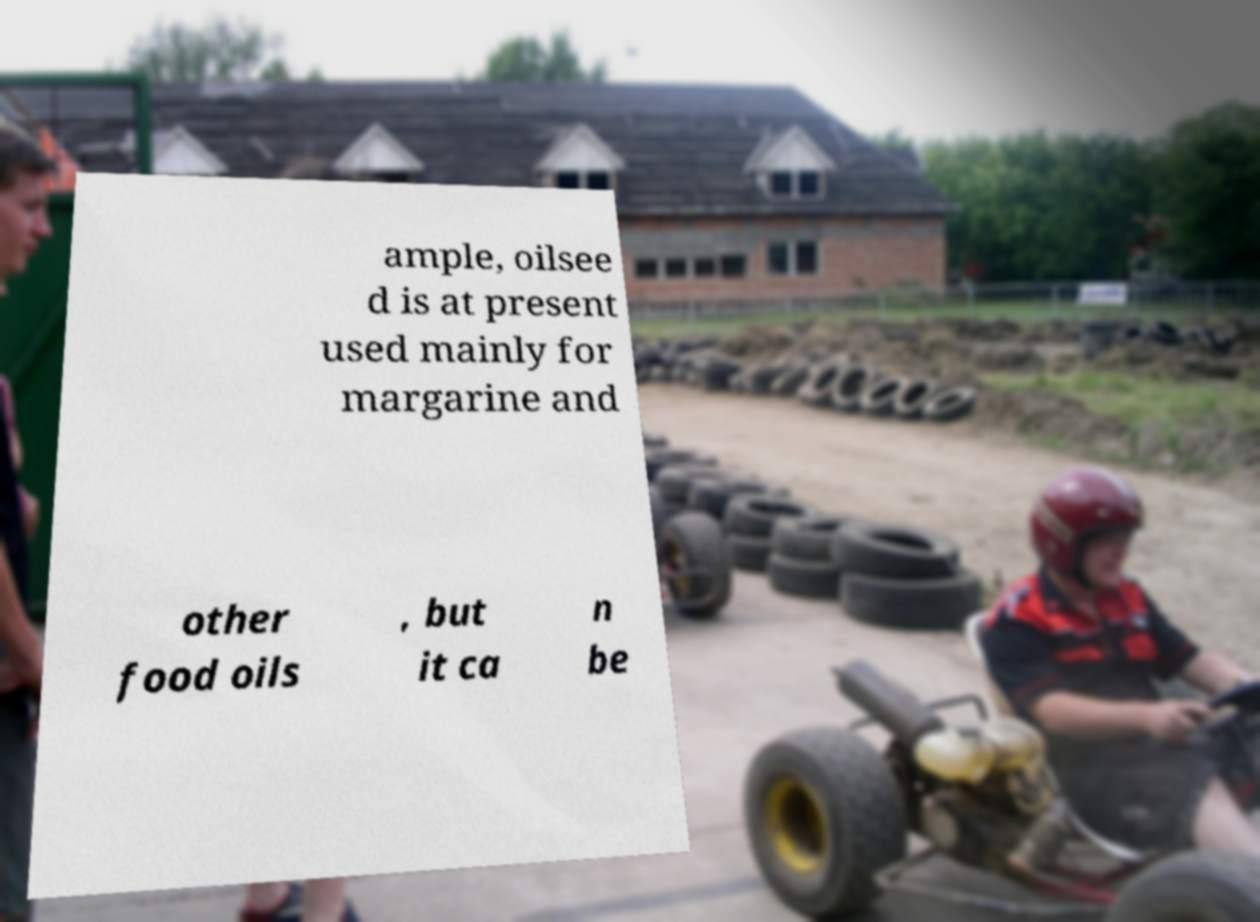Could you assist in decoding the text presented in this image and type it out clearly? ample, oilsee d is at present used mainly for margarine and other food oils , but it ca n be 